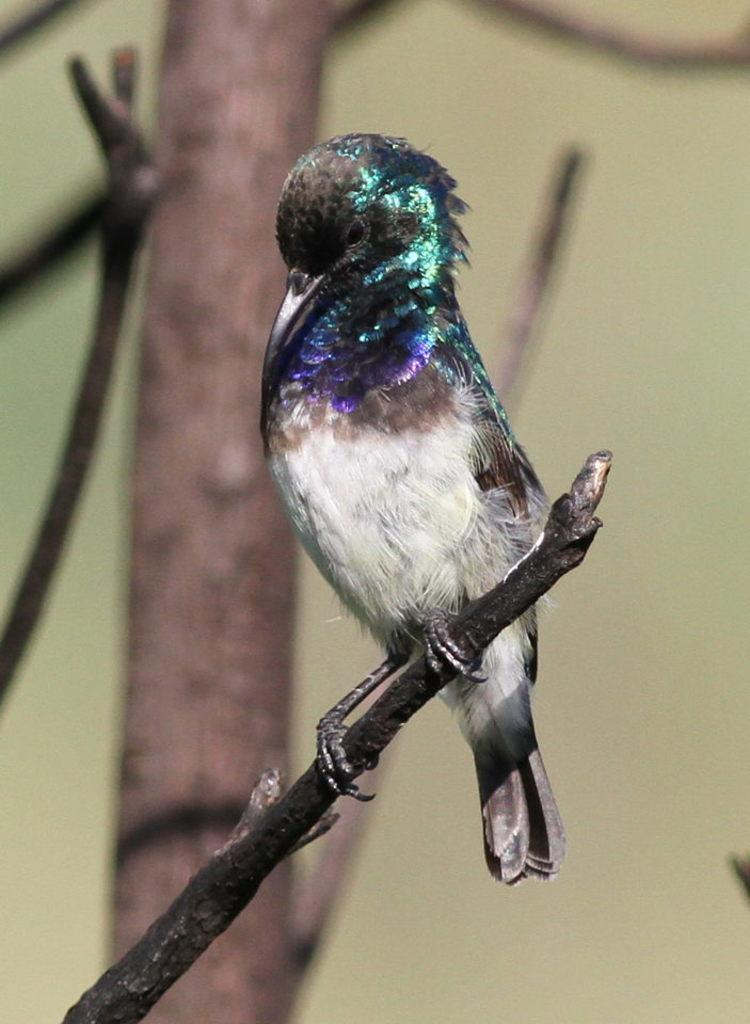What type of animal can be seen in the image? There is a bird in the image. Where is the bird located? The bird is on a tree branch. What type of temper does the bird have in the image? There is no indication of the bird's temper in the image, as it is a still photograph. Is the bird attacking anyone in the image? There is no indication of the bird attacking anyone in the image, as it is a still photograph. 